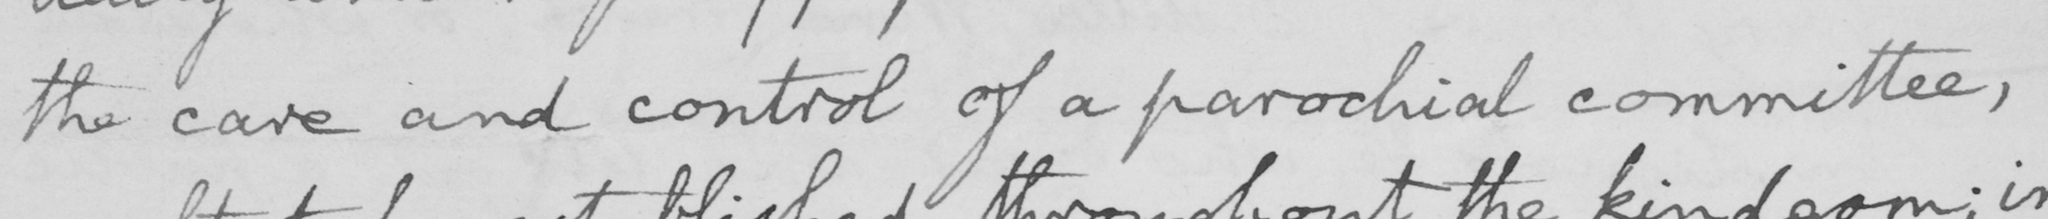What text is written in this handwritten line? the care and control of a parochial committee , 